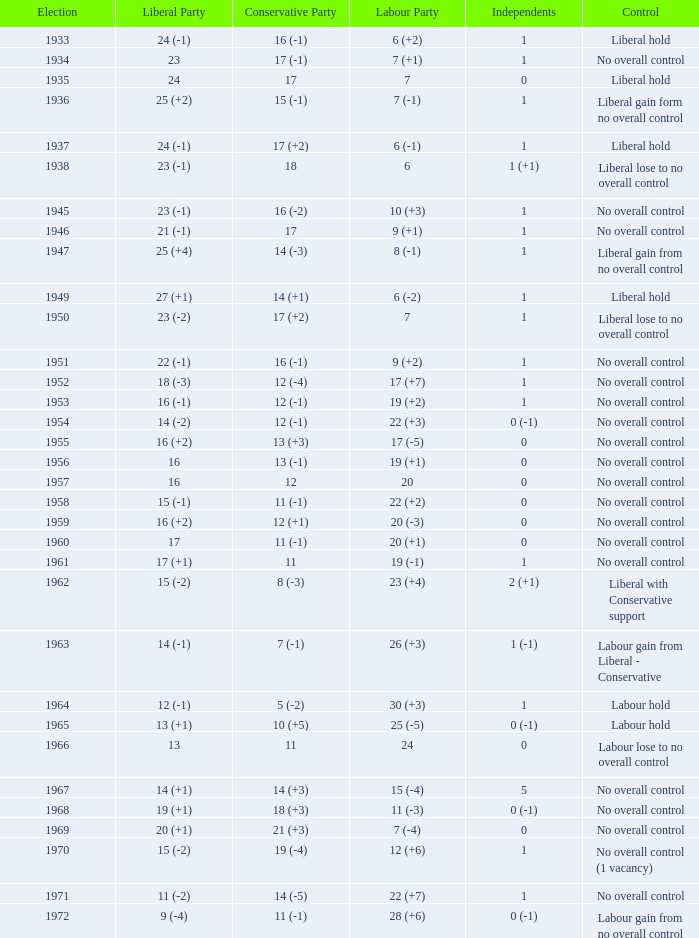What was the Liberal Party result from the election having a Conservative Party result of 16 (-1) and Labour of 6 (+2)? 24 (-1). 